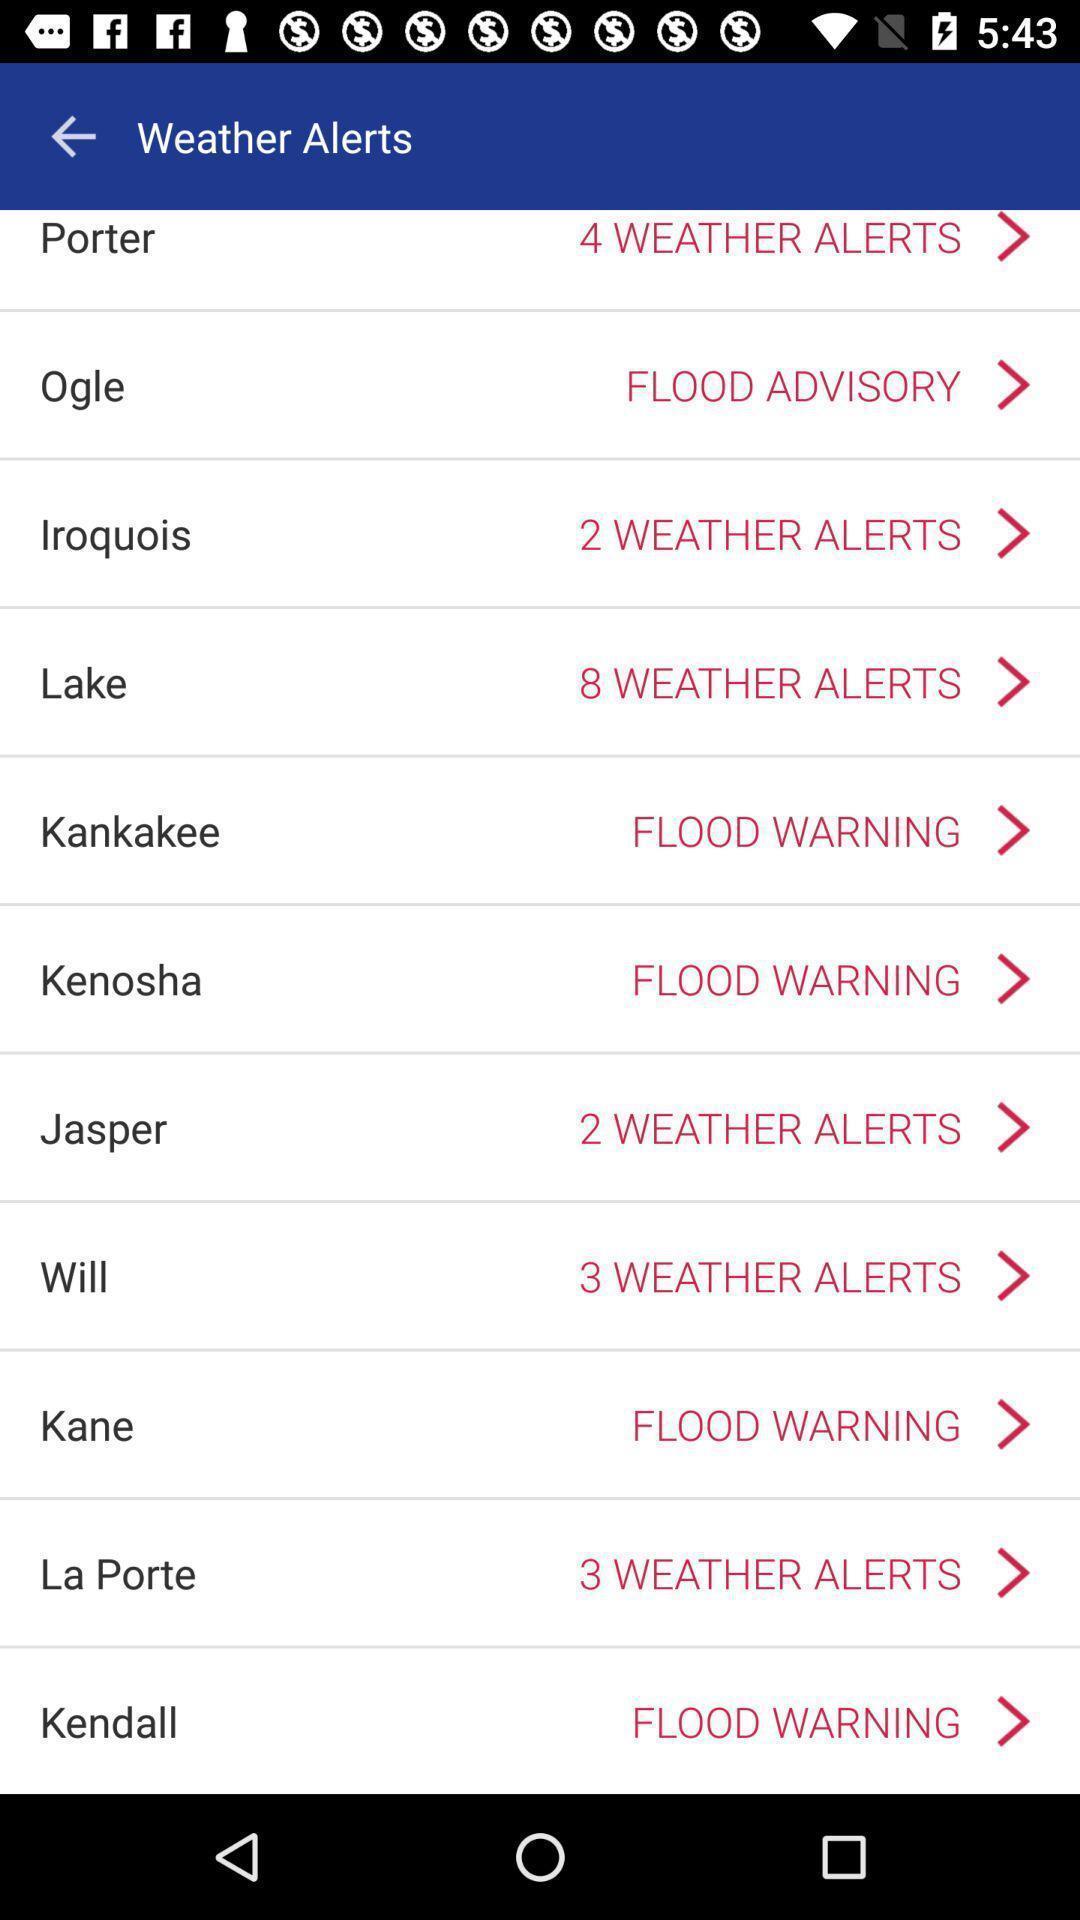Tell me about the visual elements in this screen capture. Page showing different weather alerts. 